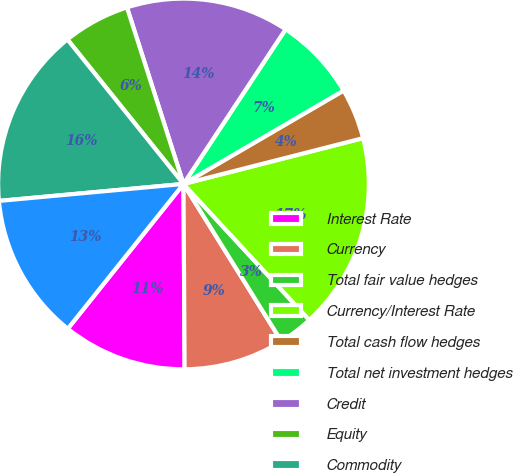Convert chart to OTSL. <chart><loc_0><loc_0><loc_500><loc_500><pie_chart><fcel>Interest Rate<fcel>Currency<fcel>Total fair value hedges<fcel>Currency/Interest Rate<fcel>Total cash flow hedges<fcel>Total net investment hedges<fcel>Credit<fcel>Equity<fcel>Commodity<fcel>Embedded Derivatives<nl><fcel>10.83%<fcel>8.77%<fcel>3.01%<fcel>17.1%<fcel>4.43%<fcel>7.31%<fcel>14.22%<fcel>5.84%<fcel>15.69%<fcel>12.81%<nl></chart> 